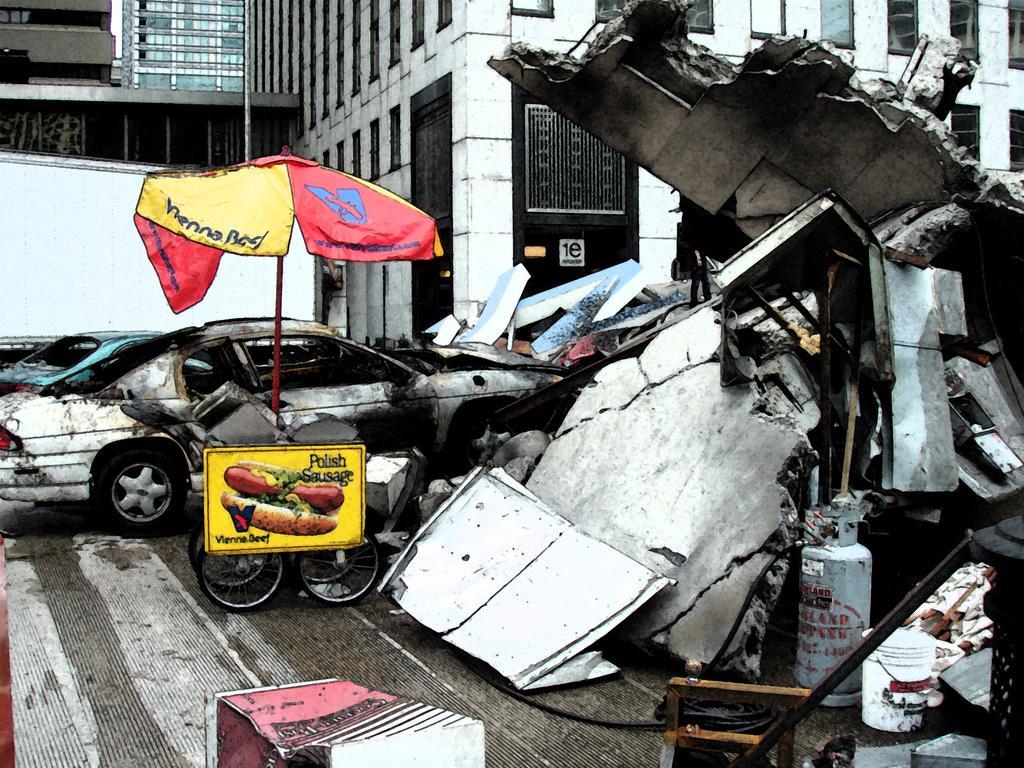In one or two sentences, can you explain what this image depicts? In this image I can see number of damaged things on the ground. On the left side of the image I can see two damaged cars, a yellow colour board, few wheels, an umbrella and on the board I can see something is written. In the background I can see few buildings and on the bottom right side of the image I can see a white colour bucket. 